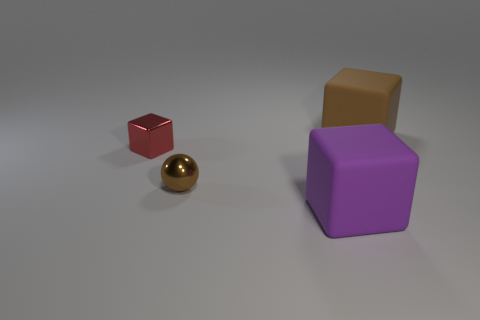Add 2 blue metal cubes. How many objects exist? 6 Subtract all spheres. How many objects are left? 3 Subtract 0 red cylinders. How many objects are left? 4 Subtract all brown shiny spheres. Subtract all purple matte blocks. How many objects are left? 2 Add 4 brown matte blocks. How many brown matte blocks are left? 5 Add 3 small green matte cylinders. How many small green matte cylinders exist? 3 